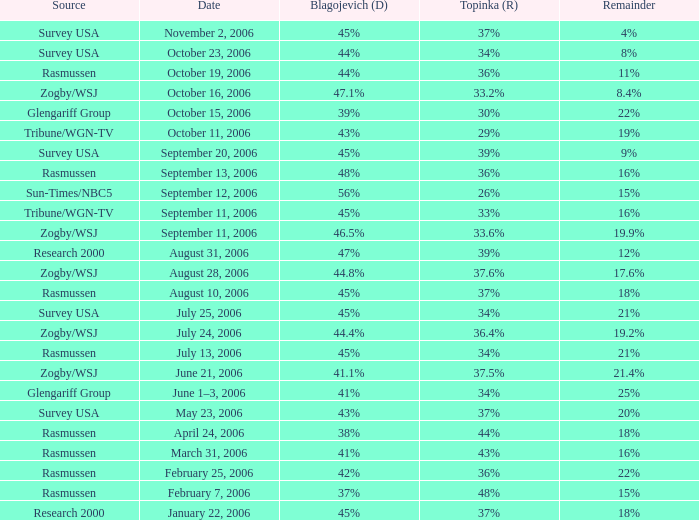Which topinka situation unfolded on january 22, 2006? 37%. 